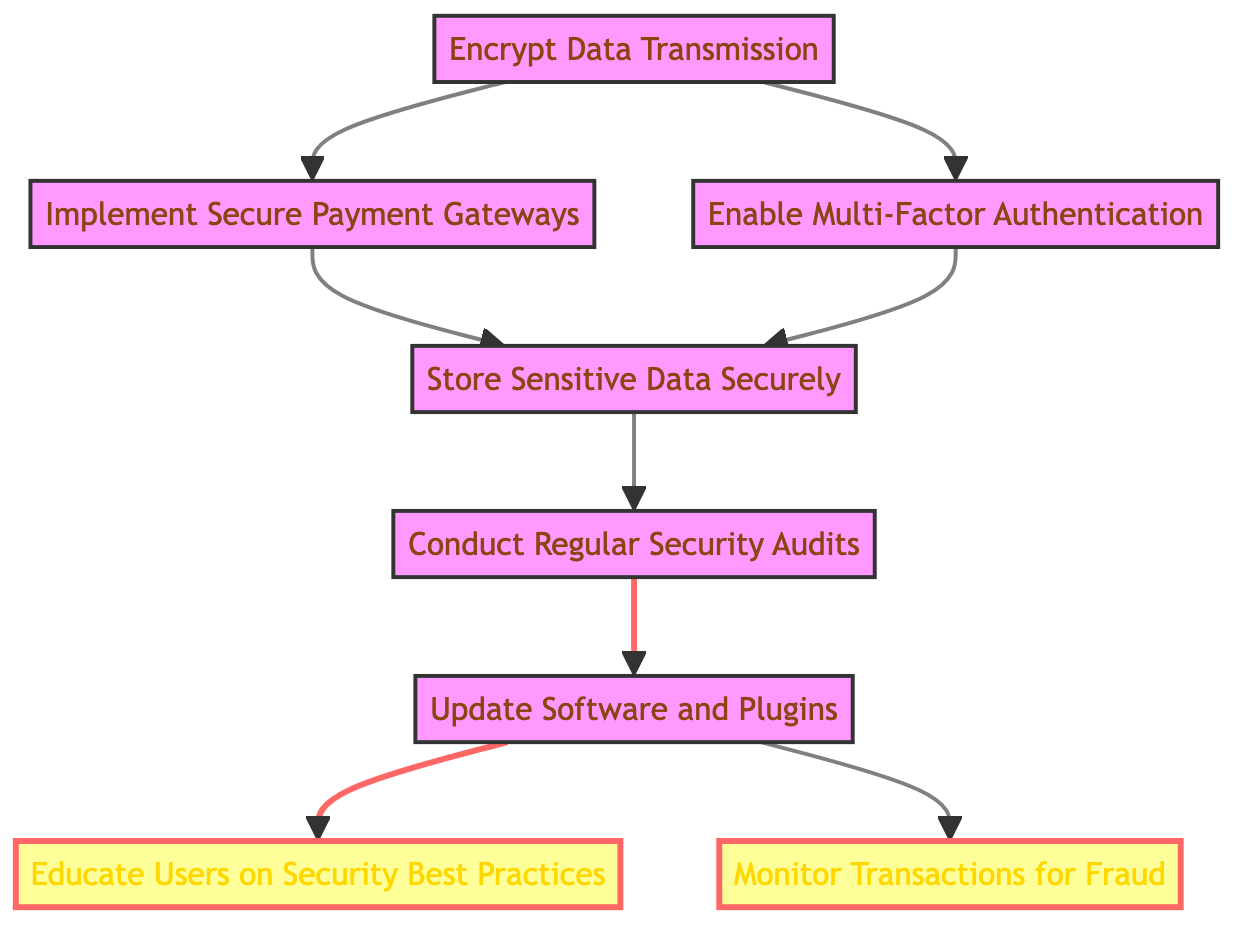What is the first step in the flow for implementing security measures? The first step is "Encrypt Data Transmission," which has no dependencies and is the starting point of the flow.
Answer: Encrypt Data Transmission How many total nodes are in the diagram? There are eight nodes present in the diagram, each representing a step in the process of implementing security measures.
Answer: Eight What are the dependencies for storing sensitive data securely? The dependencies for "Store Sensitive Data Securely" are "Implement Secure Payment Gateways" and "Enable Multi-Factor Authentication," meaning both must be completed first.
Answer: Implement Secure Payment Gateways and Enable Multi-Factor Authentication Which step requires conducting regular security audits? "Conduct Regular Security Audits" is required after "Store Sensitive Data Securely," so it cannot proceed until that step is finished.
Answer: Store Sensitive Data Securely What is the last step in the flow diagram? The last two steps are "Educate Users on Security Best Practices" and "Monitor Transactions for Fraud," which can be executed in parallel following the updates to software and plugins.
Answer: Educate Users on Security Best Practices and Monitor Transactions for Fraud Which steps are highlighted in the diagram? The highlighted steps represent the final user-facing actions, which are "Educate Users on Security Best Practices" and "Monitor Transactions for Fraud," shown with a different style to indicate their importance.
Answer: Educate Users on Security Best Practices and Monitor Transactions for Fraud What action precedes educating users on security best practices? "Update Software and Plugins" must be completed before moving on to "Educate Users on Security Best Practices," indicating that proper software management is a prerequisite.
Answer: Update Software and Plugins Which step has the most dependencies? "Conduct Regular Security Audits" has the most dependencies, needing to complete "Store Sensitive Data Securely" beforehand, which in turn requires two other steps to be completed first.
Answer: Store Sensitive Data Securely 